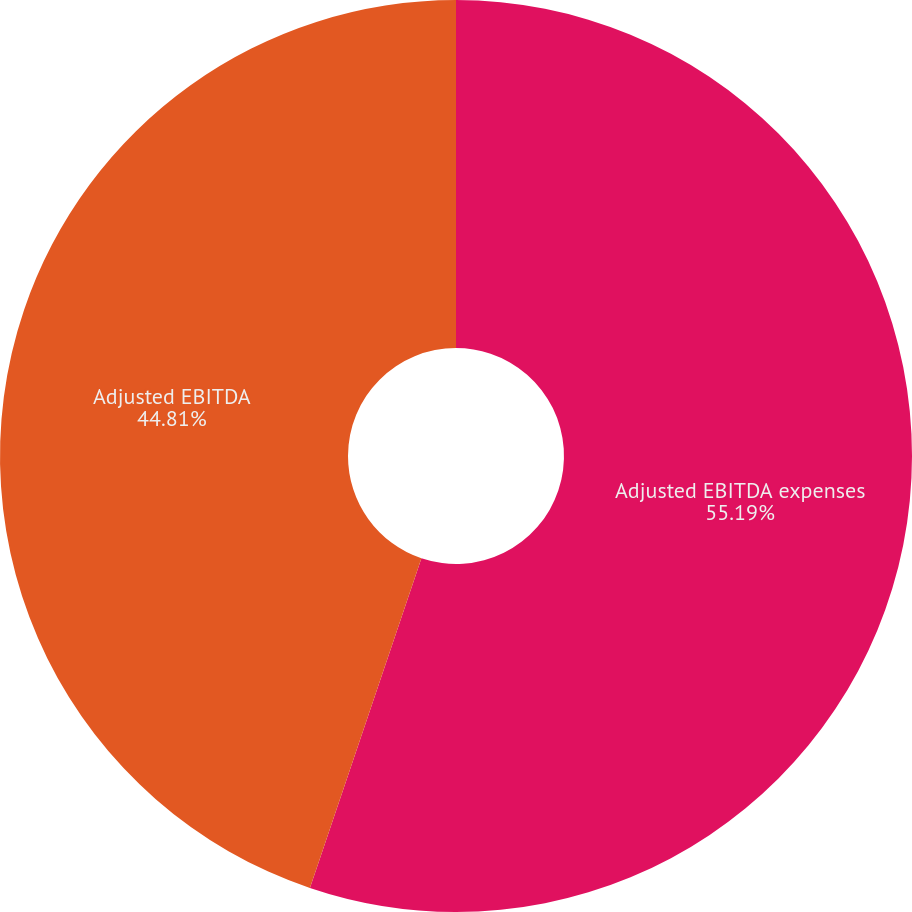Convert chart to OTSL. <chart><loc_0><loc_0><loc_500><loc_500><pie_chart><fcel>Adjusted EBITDA expenses<fcel>Adjusted EBITDA<nl><fcel>55.19%<fcel>44.81%<nl></chart> 